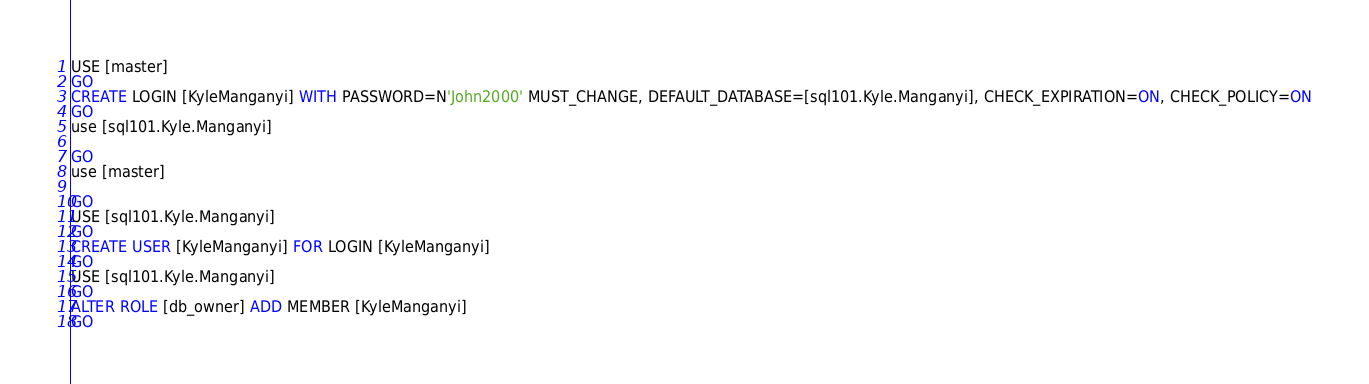<code> <loc_0><loc_0><loc_500><loc_500><_SQL_>USE [master]
GO
CREATE LOGIN [KyleManganyi] WITH PASSWORD=N'John2000' MUST_CHANGE, DEFAULT_DATABASE=[sql101.Kyle.Manganyi], CHECK_EXPIRATION=ON, CHECK_POLICY=ON
GO
use [sql101.Kyle.Manganyi]

GO
use [master]

GO
USE [sql101.Kyle.Manganyi]
GO
CREATE USER [KyleManganyi] FOR LOGIN [KyleManganyi]
GO
USE [sql101.Kyle.Manganyi]
GO
ALTER ROLE [db_owner] ADD MEMBER [KyleManganyi]
GO
</code> 